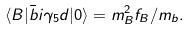Convert formula to latex. <formula><loc_0><loc_0><loc_500><loc_500>\langle B | \bar { b } i \gamma _ { 5 } d | 0 \rangle = m ^ { 2 } _ { B } f _ { B } / m _ { b } .</formula> 